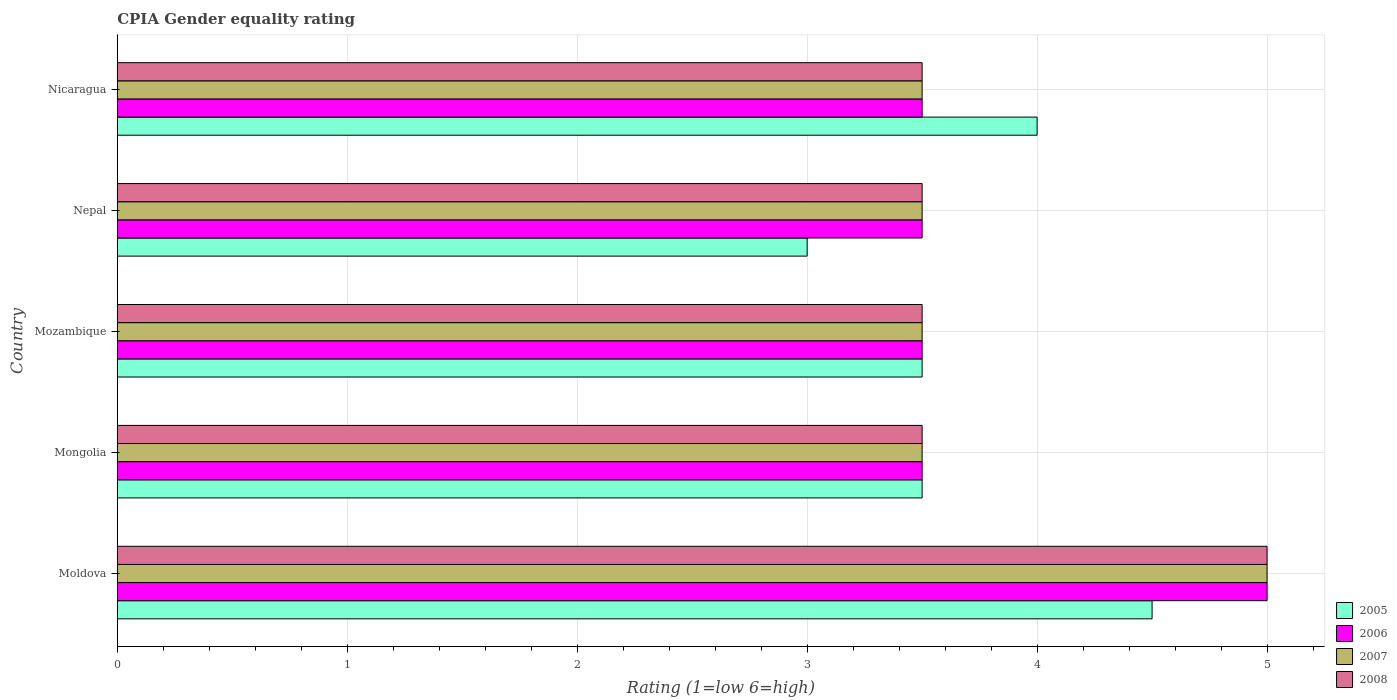Are the number of bars per tick equal to the number of legend labels?
Your answer should be very brief. Yes. How many bars are there on the 1st tick from the bottom?
Your answer should be very brief. 4. What is the label of the 4th group of bars from the top?
Your response must be concise. Mongolia. In how many cases, is the number of bars for a given country not equal to the number of legend labels?
Make the answer very short. 0. Across all countries, what is the maximum CPIA rating in 2006?
Offer a terse response. 5. Across all countries, what is the minimum CPIA rating in 2008?
Offer a terse response. 3.5. In which country was the CPIA rating in 2006 maximum?
Provide a succinct answer. Moldova. In which country was the CPIA rating in 2008 minimum?
Your answer should be very brief. Mongolia. What is the total CPIA rating in 2008 in the graph?
Ensure brevity in your answer.  19. What is the difference between the CPIA rating in 2008 in Moldova and that in Mongolia?
Your answer should be very brief. 1.5. In how many countries, is the CPIA rating in 2008 greater than 3.6 ?
Offer a very short reply. 1. Is the CPIA rating in 2008 in Moldova less than that in Nicaragua?
Offer a very short reply. No. What is the difference between the highest and the lowest CPIA rating in 2008?
Make the answer very short. 1.5. In how many countries, is the CPIA rating in 2008 greater than the average CPIA rating in 2008 taken over all countries?
Provide a succinct answer. 1. Is it the case that in every country, the sum of the CPIA rating in 2007 and CPIA rating in 2005 is greater than the sum of CPIA rating in 2006 and CPIA rating in 2008?
Your response must be concise. No. What does the 3rd bar from the bottom in Moldova represents?
Ensure brevity in your answer.  2007. How many countries are there in the graph?
Your answer should be compact. 5. Are the values on the major ticks of X-axis written in scientific E-notation?
Make the answer very short. No. How many legend labels are there?
Offer a terse response. 4. How are the legend labels stacked?
Offer a very short reply. Vertical. What is the title of the graph?
Provide a succinct answer. CPIA Gender equality rating. What is the label or title of the Y-axis?
Your answer should be very brief. Country. What is the Rating (1=low 6=high) of 2005 in Moldova?
Your answer should be very brief. 4.5. What is the Rating (1=low 6=high) of 2006 in Moldova?
Provide a succinct answer. 5. What is the Rating (1=low 6=high) in 2008 in Moldova?
Provide a succinct answer. 5. What is the Rating (1=low 6=high) of 2005 in Mongolia?
Provide a short and direct response. 3.5. What is the Rating (1=low 6=high) in 2007 in Mongolia?
Ensure brevity in your answer.  3.5. What is the Rating (1=low 6=high) of 2006 in Mozambique?
Your response must be concise. 3.5. What is the Rating (1=low 6=high) of 2007 in Mozambique?
Your answer should be very brief. 3.5. What is the Rating (1=low 6=high) of 2008 in Mozambique?
Keep it short and to the point. 3.5. What is the Rating (1=low 6=high) in 2006 in Nepal?
Ensure brevity in your answer.  3.5. What is the Rating (1=low 6=high) in 2008 in Nepal?
Your answer should be compact. 3.5. Across all countries, what is the maximum Rating (1=low 6=high) of 2005?
Your answer should be compact. 4.5. Across all countries, what is the maximum Rating (1=low 6=high) of 2007?
Your answer should be very brief. 5. Across all countries, what is the minimum Rating (1=low 6=high) of 2005?
Your answer should be very brief. 3. Across all countries, what is the minimum Rating (1=low 6=high) in 2006?
Your answer should be compact. 3.5. Across all countries, what is the minimum Rating (1=low 6=high) of 2007?
Offer a very short reply. 3.5. What is the total Rating (1=low 6=high) in 2006 in the graph?
Your answer should be very brief. 19. What is the total Rating (1=low 6=high) in 2008 in the graph?
Make the answer very short. 19. What is the difference between the Rating (1=low 6=high) of 2006 in Moldova and that in Mongolia?
Provide a succinct answer. 1.5. What is the difference between the Rating (1=low 6=high) of 2007 in Moldova and that in Mongolia?
Your answer should be compact. 1.5. What is the difference between the Rating (1=low 6=high) of 2006 in Moldova and that in Mozambique?
Your answer should be very brief. 1.5. What is the difference between the Rating (1=low 6=high) in 2008 in Moldova and that in Mozambique?
Keep it short and to the point. 1.5. What is the difference between the Rating (1=low 6=high) of 2008 in Moldova and that in Nepal?
Make the answer very short. 1.5. What is the difference between the Rating (1=low 6=high) in 2006 in Moldova and that in Nicaragua?
Your answer should be very brief. 1.5. What is the difference between the Rating (1=low 6=high) in 2007 in Moldova and that in Nicaragua?
Provide a succinct answer. 1.5. What is the difference between the Rating (1=low 6=high) of 2006 in Mongolia and that in Mozambique?
Give a very brief answer. 0. What is the difference between the Rating (1=low 6=high) of 2006 in Mongolia and that in Nepal?
Your answer should be very brief. 0. What is the difference between the Rating (1=low 6=high) in 2005 in Mongolia and that in Nicaragua?
Give a very brief answer. -0.5. What is the difference between the Rating (1=low 6=high) in 2005 in Mozambique and that in Nepal?
Your answer should be compact. 0.5. What is the difference between the Rating (1=low 6=high) in 2005 in Mozambique and that in Nicaragua?
Make the answer very short. -0.5. What is the difference between the Rating (1=low 6=high) of 2005 in Nepal and that in Nicaragua?
Your answer should be compact. -1. What is the difference between the Rating (1=low 6=high) of 2007 in Nepal and that in Nicaragua?
Give a very brief answer. 0. What is the difference between the Rating (1=low 6=high) in 2008 in Nepal and that in Nicaragua?
Provide a short and direct response. 0. What is the difference between the Rating (1=low 6=high) of 2005 in Moldova and the Rating (1=low 6=high) of 2007 in Mongolia?
Your answer should be compact. 1. What is the difference between the Rating (1=low 6=high) in 2006 in Moldova and the Rating (1=low 6=high) in 2007 in Mongolia?
Your response must be concise. 1.5. What is the difference between the Rating (1=low 6=high) in 2006 in Moldova and the Rating (1=low 6=high) in 2008 in Mongolia?
Make the answer very short. 1.5. What is the difference between the Rating (1=low 6=high) of 2005 in Moldova and the Rating (1=low 6=high) of 2007 in Mozambique?
Your answer should be compact. 1. What is the difference between the Rating (1=low 6=high) in 2005 in Moldova and the Rating (1=low 6=high) in 2008 in Mozambique?
Your response must be concise. 1. What is the difference between the Rating (1=low 6=high) of 2006 in Moldova and the Rating (1=low 6=high) of 2007 in Mozambique?
Your answer should be very brief. 1.5. What is the difference between the Rating (1=low 6=high) in 2005 in Moldova and the Rating (1=low 6=high) in 2006 in Nepal?
Give a very brief answer. 1. What is the difference between the Rating (1=low 6=high) of 2006 in Moldova and the Rating (1=low 6=high) of 2007 in Nepal?
Ensure brevity in your answer.  1.5. What is the difference between the Rating (1=low 6=high) in 2007 in Moldova and the Rating (1=low 6=high) in 2008 in Nepal?
Your response must be concise. 1.5. What is the difference between the Rating (1=low 6=high) of 2005 in Moldova and the Rating (1=low 6=high) of 2006 in Nicaragua?
Provide a succinct answer. 1. What is the difference between the Rating (1=low 6=high) in 2005 in Moldova and the Rating (1=low 6=high) in 2007 in Nicaragua?
Offer a very short reply. 1. What is the difference between the Rating (1=low 6=high) in 2006 in Moldova and the Rating (1=low 6=high) in 2007 in Nicaragua?
Your response must be concise. 1.5. What is the difference between the Rating (1=low 6=high) in 2006 in Moldova and the Rating (1=low 6=high) in 2008 in Nicaragua?
Offer a very short reply. 1.5. What is the difference between the Rating (1=low 6=high) in 2005 in Mongolia and the Rating (1=low 6=high) in 2007 in Mozambique?
Offer a terse response. 0. What is the difference between the Rating (1=low 6=high) in 2005 in Mongolia and the Rating (1=low 6=high) in 2008 in Mozambique?
Your answer should be compact. 0. What is the difference between the Rating (1=low 6=high) of 2006 in Mongolia and the Rating (1=low 6=high) of 2007 in Mozambique?
Give a very brief answer. 0. What is the difference between the Rating (1=low 6=high) of 2005 in Mongolia and the Rating (1=low 6=high) of 2006 in Nepal?
Give a very brief answer. 0. What is the difference between the Rating (1=low 6=high) in 2006 in Mongolia and the Rating (1=low 6=high) in 2007 in Nepal?
Your response must be concise. 0. What is the difference between the Rating (1=low 6=high) in 2006 in Mongolia and the Rating (1=low 6=high) in 2008 in Nepal?
Provide a succinct answer. 0. What is the difference between the Rating (1=low 6=high) of 2005 in Mongolia and the Rating (1=low 6=high) of 2006 in Nicaragua?
Make the answer very short. 0. What is the difference between the Rating (1=low 6=high) in 2005 in Mongolia and the Rating (1=low 6=high) in 2008 in Nicaragua?
Give a very brief answer. 0. What is the difference between the Rating (1=low 6=high) of 2006 in Mongolia and the Rating (1=low 6=high) of 2008 in Nicaragua?
Provide a succinct answer. 0. What is the difference between the Rating (1=low 6=high) in 2005 in Mozambique and the Rating (1=low 6=high) in 2007 in Nepal?
Give a very brief answer. 0. What is the difference between the Rating (1=low 6=high) in 2005 in Mozambique and the Rating (1=low 6=high) in 2008 in Nepal?
Provide a short and direct response. 0. What is the difference between the Rating (1=low 6=high) of 2006 in Mozambique and the Rating (1=low 6=high) of 2008 in Nepal?
Your answer should be very brief. 0. What is the difference between the Rating (1=low 6=high) in 2007 in Mozambique and the Rating (1=low 6=high) in 2008 in Nepal?
Give a very brief answer. 0. What is the difference between the Rating (1=low 6=high) in 2005 in Mozambique and the Rating (1=low 6=high) in 2008 in Nicaragua?
Offer a very short reply. 0. What is the difference between the Rating (1=low 6=high) of 2006 in Mozambique and the Rating (1=low 6=high) of 2007 in Nicaragua?
Ensure brevity in your answer.  0. What is the difference between the Rating (1=low 6=high) in 2007 in Mozambique and the Rating (1=low 6=high) in 2008 in Nicaragua?
Keep it short and to the point. 0. What is the difference between the Rating (1=low 6=high) in 2005 in Nepal and the Rating (1=low 6=high) in 2007 in Nicaragua?
Ensure brevity in your answer.  -0.5. What is the difference between the Rating (1=low 6=high) in 2005 in Nepal and the Rating (1=low 6=high) in 2008 in Nicaragua?
Your answer should be very brief. -0.5. What is the difference between the Rating (1=low 6=high) in 2006 in Nepal and the Rating (1=low 6=high) in 2008 in Nicaragua?
Provide a succinct answer. 0. What is the difference between the Rating (1=low 6=high) of 2007 in Nepal and the Rating (1=low 6=high) of 2008 in Nicaragua?
Your answer should be very brief. 0. What is the average Rating (1=low 6=high) in 2005 per country?
Your answer should be compact. 3.7. What is the difference between the Rating (1=low 6=high) of 2005 and Rating (1=low 6=high) of 2006 in Moldova?
Offer a terse response. -0.5. What is the difference between the Rating (1=low 6=high) in 2006 and Rating (1=low 6=high) in 2007 in Moldova?
Your response must be concise. 0. What is the difference between the Rating (1=low 6=high) of 2006 and Rating (1=low 6=high) of 2008 in Moldova?
Offer a very short reply. 0. What is the difference between the Rating (1=low 6=high) of 2007 and Rating (1=low 6=high) of 2008 in Mongolia?
Keep it short and to the point. 0. What is the difference between the Rating (1=low 6=high) of 2005 and Rating (1=low 6=high) of 2007 in Mozambique?
Keep it short and to the point. 0. What is the difference between the Rating (1=low 6=high) of 2006 and Rating (1=low 6=high) of 2007 in Mozambique?
Your response must be concise. 0. What is the difference between the Rating (1=low 6=high) of 2006 and Rating (1=low 6=high) of 2008 in Mozambique?
Give a very brief answer. 0. What is the difference between the Rating (1=low 6=high) of 2005 and Rating (1=low 6=high) of 2007 in Nepal?
Provide a short and direct response. -0.5. What is the difference between the Rating (1=low 6=high) in 2006 and Rating (1=low 6=high) in 2007 in Nepal?
Your answer should be very brief. 0. What is the difference between the Rating (1=low 6=high) in 2005 and Rating (1=low 6=high) in 2006 in Nicaragua?
Give a very brief answer. 0.5. What is the difference between the Rating (1=low 6=high) in 2006 and Rating (1=low 6=high) in 2007 in Nicaragua?
Keep it short and to the point. 0. What is the difference between the Rating (1=low 6=high) in 2006 and Rating (1=low 6=high) in 2008 in Nicaragua?
Make the answer very short. 0. What is the ratio of the Rating (1=low 6=high) of 2005 in Moldova to that in Mongolia?
Offer a very short reply. 1.29. What is the ratio of the Rating (1=low 6=high) in 2006 in Moldova to that in Mongolia?
Offer a terse response. 1.43. What is the ratio of the Rating (1=low 6=high) of 2007 in Moldova to that in Mongolia?
Keep it short and to the point. 1.43. What is the ratio of the Rating (1=low 6=high) in 2008 in Moldova to that in Mongolia?
Your answer should be compact. 1.43. What is the ratio of the Rating (1=low 6=high) in 2006 in Moldova to that in Mozambique?
Keep it short and to the point. 1.43. What is the ratio of the Rating (1=low 6=high) of 2007 in Moldova to that in Mozambique?
Keep it short and to the point. 1.43. What is the ratio of the Rating (1=low 6=high) of 2008 in Moldova to that in Mozambique?
Your response must be concise. 1.43. What is the ratio of the Rating (1=low 6=high) in 2006 in Moldova to that in Nepal?
Your answer should be compact. 1.43. What is the ratio of the Rating (1=low 6=high) of 2007 in Moldova to that in Nepal?
Offer a terse response. 1.43. What is the ratio of the Rating (1=low 6=high) of 2008 in Moldova to that in Nepal?
Keep it short and to the point. 1.43. What is the ratio of the Rating (1=low 6=high) of 2005 in Moldova to that in Nicaragua?
Provide a short and direct response. 1.12. What is the ratio of the Rating (1=low 6=high) in 2006 in Moldova to that in Nicaragua?
Your answer should be compact. 1.43. What is the ratio of the Rating (1=low 6=high) in 2007 in Moldova to that in Nicaragua?
Ensure brevity in your answer.  1.43. What is the ratio of the Rating (1=low 6=high) in 2008 in Moldova to that in Nicaragua?
Your answer should be very brief. 1.43. What is the ratio of the Rating (1=low 6=high) of 2006 in Mongolia to that in Mozambique?
Your answer should be compact. 1. What is the ratio of the Rating (1=low 6=high) in 2007 in Mongolia to that in Mozambique?
Your response must be concise. 1. What is the ratio of the Rating (1=low 6=high) of 2008 in Mongolia to that in Mozambique?
Provide a short and direct response. 1. What is the ratio of the Rating (1=low 6=high) in 2005 in Mongolia to that in Nepal?
Provide a short and direct response. 1.17. What is the ratio of the Rating (1=low 6=high) in 2007 in Mongolia to that in Nepal?
Your answer should be very brief. 1. What is the ratio of the Rating (1=low 6=high) of 2008 in Mongolia to that in Nepal?
Keep it short and to the point. 1. What is the ratio of the Rating (1=low 6=high) of 2007 in Mongolia to that in Nicaragua?
Your answer should be compact. 1. What is the ratio of the Rating (1=low 6=high) in 2006 in Mozambique to that in Nepal?
Your answer should be very brief. 1. What is the ratio of the Rating (1=low 6=high) in 2007 in Mozambique to that in Nepal?
Give a very brief answer. 1. What is the ratio of the Rating (1=low 6=high) of 2008 in Mozambique to that in Nepal?
Your response must be concise. 1. What is the ratio of the Rating (1=low 6=high) of 2006 in Mozambique to that in Nicaragua?
Provide a short and direct response. 1. What is the ratio of the Rating (1=low 6=high) of 2007 in Nepal to that in Nicaragua?
Make the answer very short. 1. What is the ratio of the Rating (1=low 6=high) in 2008 in Nepal to that in Nicaragua?
Keep it short and to the point. 1. What is the difference between the highest and the second highest Rating (1=low 6=high) in 2005?
Give a very brief answer. 0.5. What is the difference between the highest and the second highest Rating (1=low 6=high) in 2006?
Offer a very short reply. 1.5. What is the difference between the highest and the second highest Rating (1=low 6=high) of 2008?
Offer a very short reply. 1.5. What is the difference between the highest and the lowest Rating (1=low 6=high) in 2005?
Offer a terse response. 1.5. What is the difference between the highest and the lowest Rating (1=low 6=high) of 2006?
Offer a very short reply. 1.5. What is the difference between the highest and the lowest Rating (1=low 6=high) of 2008?
Make the answer very short. 1.5. 